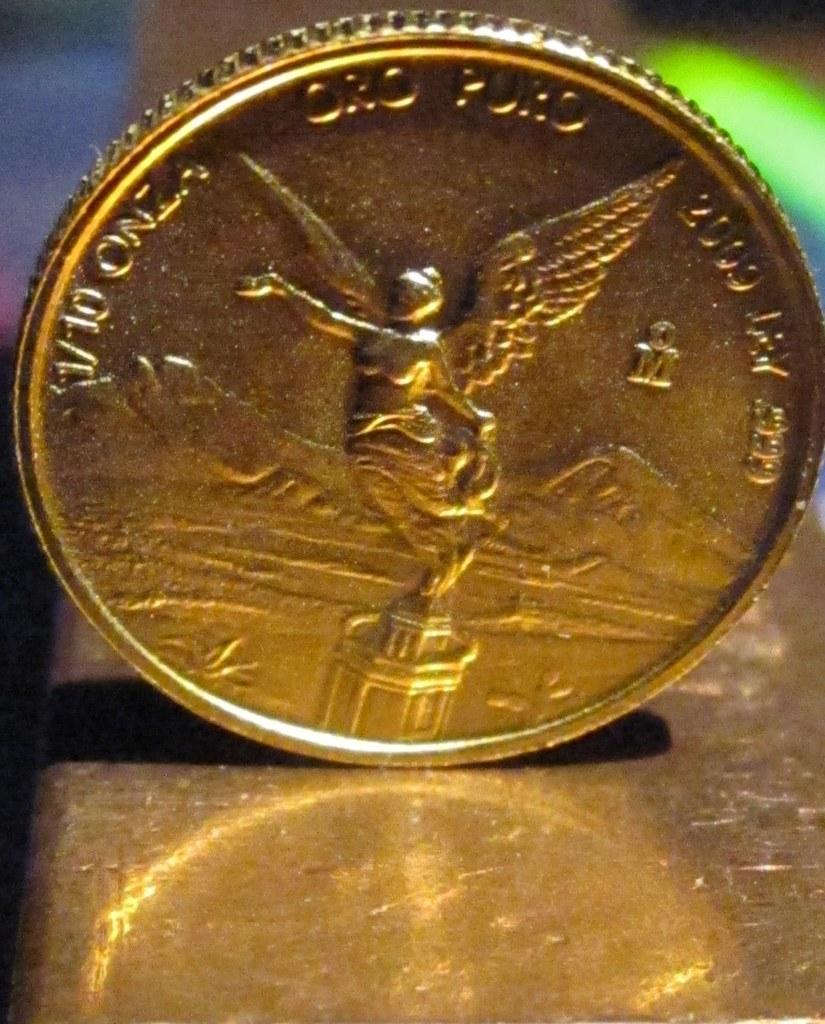What is the first word on the coin?
Ensure brevity in your answer.  Onza. 